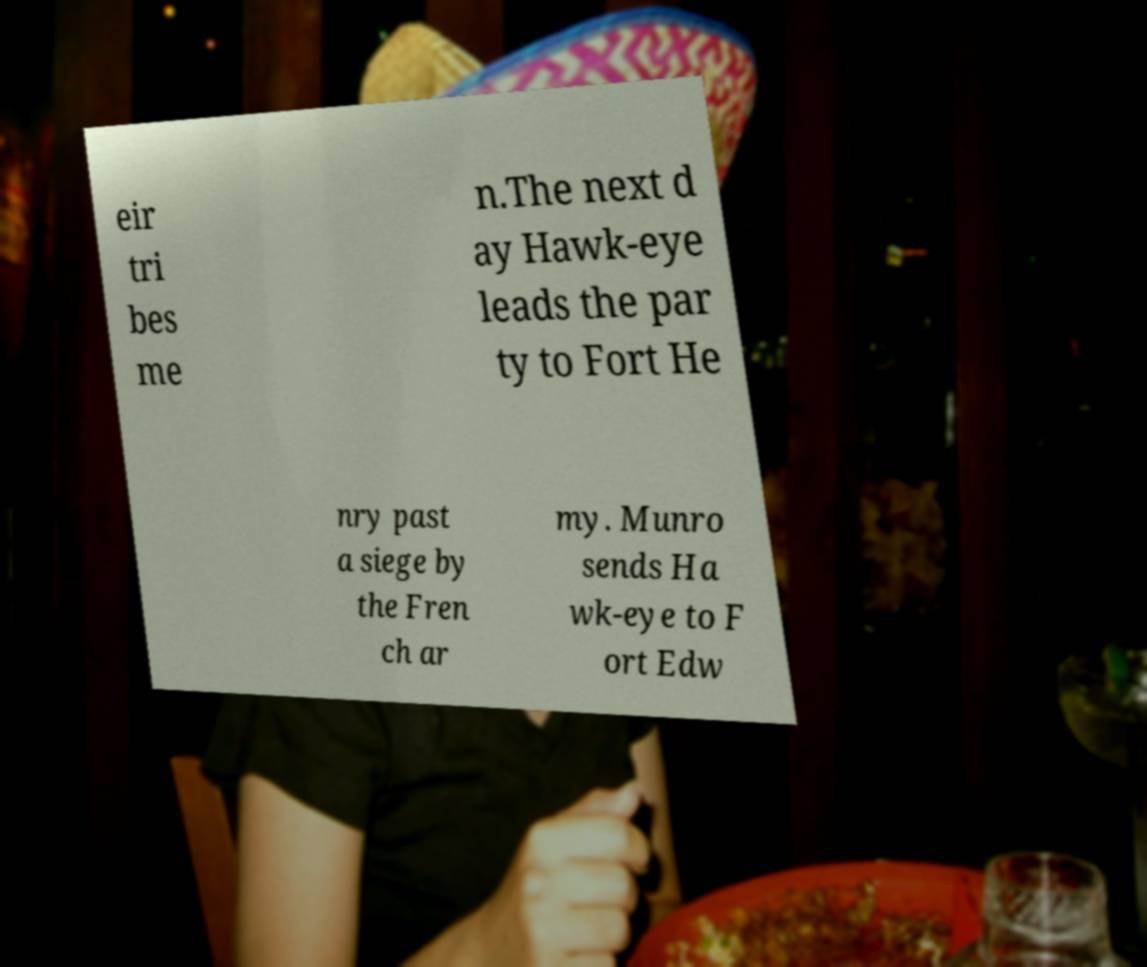Can you read and provide the text displayed in the image?This photo seems to have some interesting text. Can you extract and type it out for me? eir tri bes me n.The next d ay Hawk-eye leads the par ty to Fort He nry past a siege by the Fren ch ar my. Munro sends Ha wk-eye to F ort Edw 